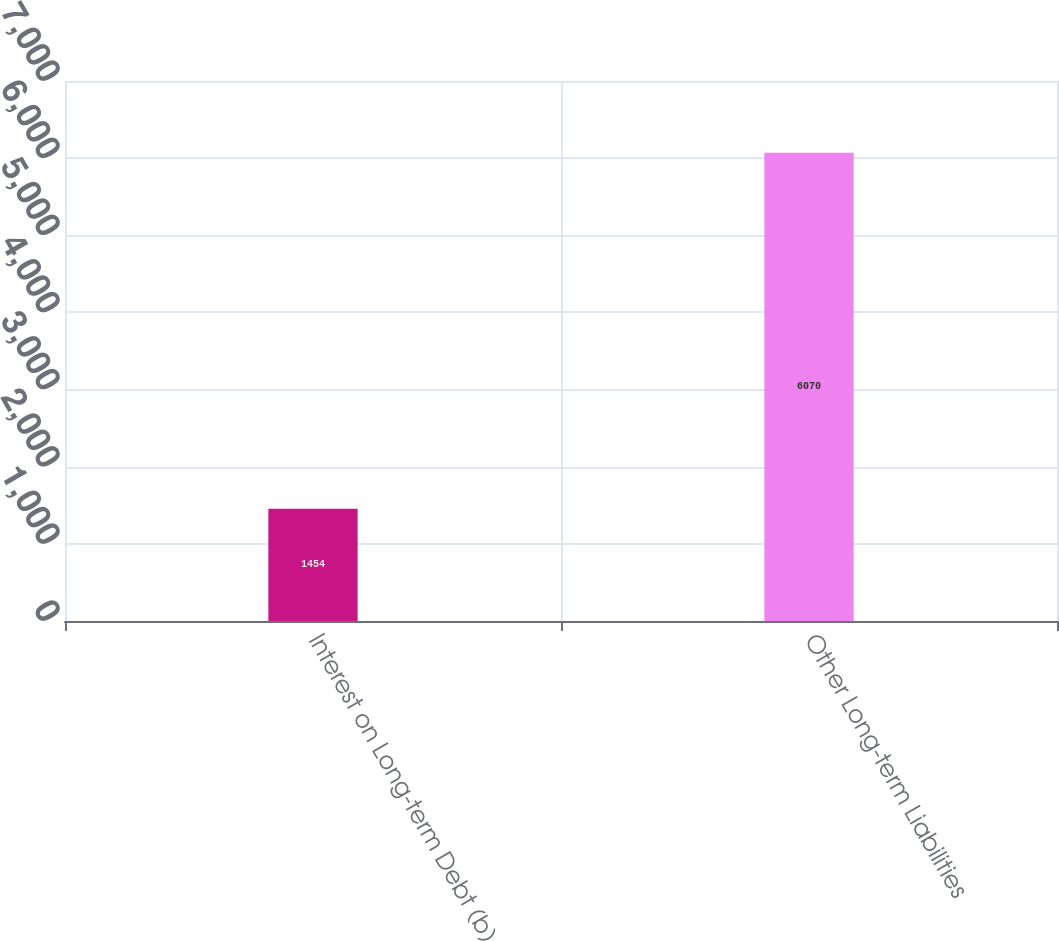<chart> <loc_0><loc_0><loc_500><loc_500><bar_chart><fcel>Interest on Long-term Debt (b)<fcel>Other Long-term Liabilities<nl><fcel>1454<fcel>6070<nl></chart> 